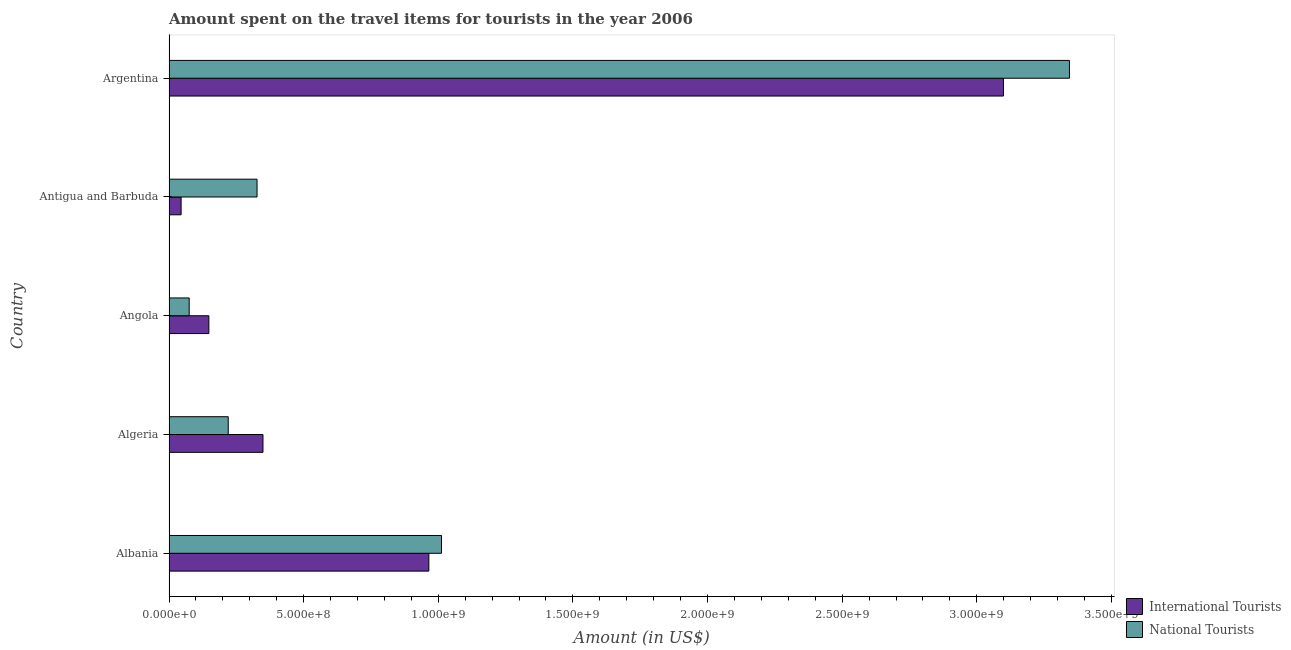How many different coloured bars are there?
Offer a very short reply. 2. Are the number of bars on each tick of the Y-axis equal?
Ensure brevity in your answer.  Yes. How many bars are there on the 5th tick from the top?
Provide a succinct answer. 2. What is the label of the 2nd group of bars from the top?
Provide a short and direct response. Antigua and Barbuda. What is the amount spent on travel items of international tourists in Antigua and Barbuda?
Your answer should be very brief. 4.50e+07. Across all countries, what is the maximum amount spent on travel items of national tourists?
Your answer should be compact. 3.34e+09. Across all countries, what is the minimum amount spent on travel items of national tourists?
Ensure brevity in your answer.  7.50e+07. In which country was the amount spent on travel items of international tourists minimum?
Give a very brief answer. Antigua and Barbuda. What is the total amount spent on travel items of international tourists in the graph?
Make the answer very short. 4.61e+09. What is the difference between the amount spent on travel items of international tourists in Algeria and that in Argentina?
Your answer should be very brief. -2.75e+09. What is the difference between the amount spent on travel items of national tourists in Angola and the amount spent on travel items of international tourists in Argentina?
Offer a terse response. -3.02e+09. What is the average amount spent on travel items of international tourists per country?
Your answer should be compact. 9.21e+08. What is the difference between the amount spent on travel items of international tourists and amount spent on travel items of national tourists in Argentina?
Give a very brief answer. -2.45e+08. What is the ratio of the amount spent on travel items of international tourists in Angola to that in Argentina?
Offer a very short reply. 0.05. What is the difference between the highest and the second highest amount spent on travel items of national tourists?
Ensure brevity in your answer.  2.33e+09. What is the difference between the highest and the lowest amount spent on travel items of international tourists?
Your answer should be very brief. 3.05e+09. In how many countries, is the amount spent on travel items of national tourists greater than the average amount spent on travel items of national tourists taken over all countries?
Give a very brief answer. 2. Is the sum of the amount spent on travel items of international tourists in Albania and Argentina greater than the maximum amount spent on travel items of national tourists across all countries?
Provide a succinct answer. Yes. What does the 2nd bar from the top in Antigua and Barbuda represents?
Your answer should be compact. International Tourists. What does the 1st bar from the bottom in Albania represents?
Your answer should be very brief. International Tourists. How many bars are there?
Make the answer very short. 10. Are all the bars in the graph horizontal?
Offer a terse response. Yes. How many countries are there in the graph?
Your answer should be very brief. 5. What is the difference between two consecutive major ticks on the X-axis?
Provide a succinct answer. 5.00e+08. Are the values on the major ticks of X-axis written in scientific E-notation?
Your response must be concise. Yes. How many legend labels are there?
Offer a very short reply. 2. What is the title of the graph?
Your response must be concise. Amount spent on the travel items for tourists in the year 2006. What is the label or title of the Y-axis?
Your answer should be very brief. Country. What is the Amount (in US$) in International Tourists in Albania?
Ensure brevity in your answer.  9.65e+08. What is the Amount (in US$) in National Tourists in Albania?
Make the answer very short. 1.01e+09. What is the Amount (in US$) in International Tourists in Algeria?
Keep it short and to the point. 3.49e+08. What is the Amount (in US$) of National Tourists in Algeria?
Keep it short and to the point. 2.20e+08. What is the Amount (in US$) in International Tourists in Angola?
Offer a very short reply. 1.48e+08. What is the Amount (in US$) in National Tourists in Angola?
Provide a succinct answer. 7.50e+07. What is the Amount (in US$) in International Tourists in Antigua and Barbuda?
Make the answer very short. 4.50e+07. What is the Amount (in US$) of National Tourists in Antigua and Barbuda?
Keep it short and to the point. 3.27e+08. What is the Amount (in US$) in International Tourists in Argentina?
Ensure brevity in your answer.  3.10e+09. What is the Amount (in US$) in National Tourists in Argentina?
Your answer should be very brief. 3.34e+09. Across all countries, what is the maximum Amount (in US$) in International Tourists?
Keep it short and to the point. 3.10e+09. Across all countries, what is the maximum Amount (in US$) in National Tourists?
Keep it short and to the point. 3.34e+09. Across all countries, what is the minimum Amount (in US$) of International Tourists?
Offer a very short reply. 4.50e+07. Across all countries, what is the minimum Amount (in US$) in National Tourists?
Provide a short and direct response. 7.50e+07. What is the total Amount (in US$) in International Tourists in the graph?
Give a very brief answer. 4.61e+09. What is the total Amount (in US$) of National Tourists in the graph?
Offer a very short reply. 4.98e+09. What is the difference between the Amount (in US$) of International Tourists in Albania and that in Algeria?
Ensure brevity in your answer.  6.16e+08. What is the difference between the Amount (in US$) of National Tourists in Albania and that in Algeria?
Your response must be concise. 7.92e+08. What is the difference between the Amount (in US$) in International Tourists in Albania and that in Angola?
Your response must be concise. 8.17e+08. What is the difference between the Amount (in US$) of National Tourists in Albania and that in Angola?
Your answer should be very brief. 9.37e+08. What is the difference between the Amount (in US$) of International Tourists in Albania and that in Antigua and Barbuda?
Make the answer very short. 9.20e+08. What is the difference between the Amount (in US$) in National Tourists in Albania and that in Antigua and Barbuda?
Offer a terse response. 6.85e+08. What is the difference between the Amount (in US$) in International Tourists in Albania and that in Argentina?
Offer a very short reply. -2.13e+09. What is the difference between the Amount (in US$) of National Tourists in Albania and that in Argentina?
Your response must be concise. -2.33e+09. What is the difference between the Amount (in US$) in International Tourists in Algeria and that in Angola?
Offer a terse response. 2.01e+08. What is the difference between the Amount (in US$) of National Tourists in Algeria and that in Angola?
Give a very brief answer. 1.45e+08. What is the difference between the Amount (in US$) in International Tourists in Algeria and that in Antigua and Barbuda?
Ensure brevity in your answer.  3.04e+08. What is the difference between the Amount (in US$) in National Tourists in Algeria and that in Antigua and Barbuda?
Your answer should be very brief. -1.07e+08. What is the difference between the Amount (in US$) in International Tourists in Algeria and that in Argentina?
Make the answer very short. -2.75e+09. What is the difference between the Amount (in US$) of National Tourists in Algeria and that in Argentina?
Give a very brief answer. -3.12e+09. What is the difference between the Amount (in US$) of International Tourists in Angola and that in Antigua and Barbuda?
Provide a short and direct response. 1.03e+08. What is the difference between the Amount (in US$) in National Tourists in Angola and that in Antigua and Barbuda?
Keep it short and to the point. -2.52e+08. What is the difference between the Amount (in US$) of International Tourists in Angola and that in Argentina?
Provide a short and direct response. -2.95e+09. What is the difference between the Amount (in US$) of National Tourists in Angola and that in Argentina?
Give a very brief answer. -3.27e+09. What is the difference between the Amount (in US$) in International Tourists in Antigua and Barbuda and that in Argentina?
Provide a short and direct response. -3.05e+09. What is the difference between the Amount (in US$) of National Tourists in Antigua and Barbuda and that in Argentina?
Your response must be concise. -3.02e+09. What is the difference between the Amount (in US$) of International Tourists in Albania and the Amount (in US$) of National Tourists in Algeria?
Provide a succinct answer. 7.45e+08. What is the difference between the Amount (in US$) of International Tourists in Albania and the Amount (in US$) of National Tourists in Angola?
Your answer should be compact. 8.90e+08. What is the difference between the Amount (in US$) in International Tourists in Albania and the Amount (in US$) in National Tourists in Antigua and Barbuda?
Keep it short and to the point. 6.38e+08. What is the difference between the Amount (in US$) of International Tourists in Albania and the Amount (in US$) of National Tourists in Argentina?
Offer a very short reply. -2.38e+09. What is the difference between the Amount (in US$) of International Tourists in Algeria and the Amount (in US$) of National Tourists in Angola?
Offer a terse response. 2.74e+08. What is the difference between the Amount (in US$) in International Tourists in Algeria and the Amount (in US$) in National Tourists in Antigua and Barbuda?
Ensure brevity in your answer.  2.20e+07. What is the difference between the Amount (in US$) in International Tourists in Algeria and the Amount (in US$) in National Tourists in Argentina?
Provide a short and direct response. -3.00e+09. What is the difference between the Amount (in US$) of International Tourists in Angola and the Amount (in US$) of National Tourists in Antigua and Barbuda?
Offer a very short reply. -1.79e+08. What is the difference between the Amount (in US$) in International Tourists in Angola and the Amount (in US$) in National Tourists in Argentina?
Give a very brief answer. -3.20e+09. What is the difference between the Amount (in US$) in International Tourists in Antigua and Barbuda and the Amount (in US$) in National Tourists in Argentina?
Make the answer very short. -3.30e+09. What is the average Amount (in US$) in International Tourists per country?
Provide a short and direct response. 9.21e+08. What is the average Amount (in US$) in National Tourists per country?
Offer a terse response. 9.96e+08. What is the difference between the Amount (in US$) of International Tourists and Amount (in US$) of National Tourists in Albania?
Give a very brief answer. -4.70e+07. What is the difference between the Amount (in US$) in International Tourists and Amount (in US$) in National Tourists in Algeria?
Keep it short and to the point. 1.29e+08. What is the difference between the Amount (in US$) of International Tourists and Amount (in US$) of National Tourists in Angola?
Offer a very short reply. 7.30e+07. What is the difference between the Amount (in US$) in International Tourists and Amount (in US$) in National Tourists in Antigua and Barbuda?
Ensure brevity in your answer.  -2.82e+08. What is the difference between the Amount (in US$) of International Tourists and Amount (in US$) of National Tourists in Argentina?
Your answer should be very brief. -2.45e+08. What is the ratio of the Amount (in US$) of International Tourists in Albania to that in Algeria?
Keep it short and to the point. 2.77. What is the ratio of the Amount (in US$) of National Tourists in Albania to that in Algeria?
Provide a short and direct response. 4.6. What is the ratio of the Amount (in US$) in International Tourists in Albania to that in Angola?
Offer a terse response. 6.52. What is the ratio of the Amount (in US$) of National Tourists in Albania to that in Angola?
Keep it short and to the point. 13.49. What is the ratio of the Amount (in US$) in International Tourists in Albania to that in Antigua and Barbuda?
Offer a very short reply. 21.44. What is the ratio of the Amount (in US$) of National Tourists in Albania to that in Antigua and Barbuda?
Provide a short and direct response. 3.09. What is the ratio of the Amount (in US$) of International Tourists in Albania to that in Argentina?
Make the answer very short. 0.31. What is the ratio of the Amount (in US$) of National Tourists in Albania to that in Argentina?
Provide a succinct answer. 0.3. What is the ratio of the Amount (in US$) of International Tourists in Algeria to that in Angola?
Offer a terse response. 2.36. What is the ratio of the Amount (in US$) of National Tourists in Algeria to that in Angola?
Offer a terse response. 2.93. What is the ratio of the Amount (in US$) of International Tourists in Algeria to that in Antigua and Barbuda?
Give a very brief answer. 7.76. What is the ratio of the Amount (in US$) in National Tourists in Algeria to that in Antigua and Barbuda?
Your response must be concise. 0.67. What is the ratio of the Amount (in US$) of International Tourists in Algeria to that in Argentina?
Your answer should be compact. 0.11. What is the ratio of the Amount (in US$) in National Tourists in Algeria to that in Argentina?
Provide a succinct answer. 0.07. What is the ratio of the Amount (in US$) in International Tourists in Angola to that in Antigua and Barbuda?
Ensure brevity in your answer.  3.29. What is the ratio of the Amount (in US$) of National Tourists in Angola to that in Antigua and Barbuda?
Give a very brief answer. 0.23. What is the ratio of the Amount (in US$) in International Tourists in Angola to that in Argentina?
Offer a terse response. 0.05. What is the ratio of the Amount (in US$) of National Tourists in Angola to that in Argentina?
Provide a short and direct response. 0.02. What is the ratio of the Amount (in US$) in International Tourists in Antigua and Barbuda to that in Argentina?
Offer a very short reply. 0.01. What is the ratio of the Amount (in US$) of National Tourists in Antigua and Barbuda to that in Argentina?
Your answer should be very brief. 0.1. What is the difference between the highest and the second highest Amount (in US$) of International Tourists?
Offer a very short reply. 2.13e+09. What is the difference between the highest and the second highest Amount (in US$) in National Tourists?
Provide a short and direct response. 2.33e+09. What is the difference between the highest and the lowest Amount (in US$) in International Tourists?
Provide a short and direct response. 3.05e+09. What is the difference between the highest and the lowest Amount (in US$) in National Tourists?
Make the answer very short. 3.27e+09. 